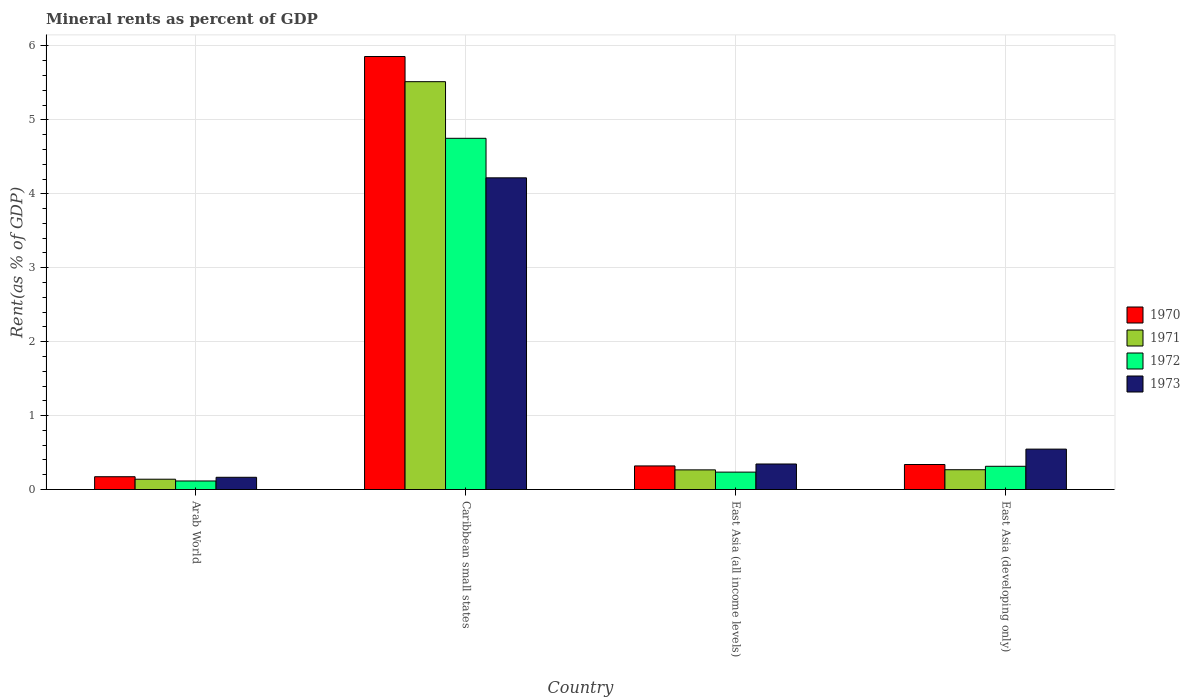How many bars are there on the 2nd tick from the left?
Make the answer very short. 4. How many bars are there on the 2nd tick from the right?
Ensure brevity in your answer.  4. What is the label of the 1st group of bars from the left?
Offer a very short reply. Arab World. What is the mineral rent in 1973 in Arab World?
Your response must be concise. 0.17. Across all countries, what is the maximum mineral rent in 1970?
Your answer should be compact. 5.86. Across all countries, what is the minimum mineral rent in 1970?
Ensure brevity in your answer.  0.17. In which country was the mineral rent in 1973 maximum?
Make the answer very short. Caribbean small states. In which country was the mineral rent in 1972 minimum?
Ensure brevity in your answer.  Arab World. What is the total mineral rent in 1973 in the graph?
Provide a succinct answer. 5.27. What is the difference between the mineral rent in 1972 in Caribbean small states and that in East Asia (developing only)?
Provide a short and direct response. 4.44. What is the difference between the mineral rent in 1970 in Caribbean small states and the mineral rent in 1972 in East Asia (developing only)?
Provide a short and direct response. 5.54. What is the average mineral rent in 1973 per country?
Your answer should be compact. 1.32. What is the difference between the mineral rent of/in 1971 and mineral rent of/in 1972 in Caribbean small states?
Your answer should be compact. 0.77. In how many countries, is the mineral rent in 1972 greater than 3 %?
Offer a very short reply. 1. What is the ratio of the mineral rent in 1972 in Caribbean small states to that in East Asia (developing only)?
Your answer should be compact. 15.12. Is the mineral rent in 1970 in Caribbean small states less than that in East Asia (all income levels)?
Make the answer very short. No. Is the difference between the mineral rent in 1971 in East Asia (all income levels) and East Asia (developing only) greater than the difference between the mineral rent in 1972 in East Asia (all income levels) and East Asia (developing only)?
Offer a very short reply. Yes. What is the difference between the highest and the second highest mineral rent in 1971?
Your answer should be compact. -5.25. What is the difference between the highest and the lowest mineral rent in 1972?
Provide a short and direct response. 4.63. What does the 1st bar from the left in East Asia (developing only) represents?
Your answer should be compact. 1970. Is it the case that in every country, the sum of the mineral rent in 1973 and mineral rent in 1971 is greater than the mineral rent in 1972?
Your answer should be compact. Yes. Are all the bars in the graph horizontal?
Your answer should be very brief. No. How many countries are there in the graph?
Give a very brief answer. 4. What is the difference between two consecutive major ticks on the Y-axis?
Offer a terse response. 1. Are the values on the major ticks of Y-axis written in scientific E-notation?
Give a very brief answer. No. Does the graph contain any zero values?
Provide a succinct answer. No. Does the graph contain grids?
Make the answer very short. Yes. How many legend labels are there?
Make the answer very short. 4. What is the title of the graph?
Your response must be concise. Mineral rents as percent of GDP. Does "1995" appear as one of the legend labels in the graph?
Your answer should be compact. No. What is the label or title of the Y-axis?
Provide a succinct answer. Rent(as % of GDP). What is the Rent(as % of GDP) in 1970 in Arab World?
Offer a terse response. 0.17. What is the Rent(as % of GDP) in 1971 in Arab World?
Ensure brevity in your answer.  0.14. What is the Rent(as % of GDP) in 1972 in Arab World?
Keep it short and to the point. 0.12. What is the Rent(as % of GDP) of 1973 in Arab World?
Provide a short and direct response. 0.17. What is the Rent(as % of GDP) of 1970 in Caribbean small states?
Ensure brevity in your answer.  5.86. What is the Rent(as % of GDP) in 1971 in Caribbean small states?
Your response must be concise. 5.52. What is the Rent(as % of GDP) of 1972 in Caribbean small states?
Offer a very short reply. 4.75. What is the Rent(as % of GDP) in 1973 in Caribbean small states?
Keep it short and to the point. 4.22. What is the Rent(as % of GDP) of 1970 in East Asia (all income levels)?
Keep it short and to the point. 0.32. What is the Rent(as % of GDP) of 1971 in East Asia (all income levels)?
Keep it short and to the point. 0.27. What is the Rent(as % of GDP) of 1972 in East Asia (all income levels)?
Ensure brevity in your answer.  0.24. What is the Rent(as % of GDP) in 1973 in East Asia (all income levels)?
Your answer should be compact. 0.35. What is the Rent(as % of GDP) in 1970 in East Asia (developing only)?
Provide a short and direct response. 0.34. What is the Rent(as % of GDP) of 1971 in East Asia (developing only)?
Offer a very short reply. 0.27. What is the Rent(as % of GDP) in 1972 in East Asia (developing only)?
Give a very brief answer. 0.31. What is the Rent(as % of GDP) of 1973 in East Asia (developing only)?
Keep it short and to the point. 0.55. Across all countries, what is the maximum Rent(as % of GDP) in 1970?
Give a very brief answer. 5.86. Across all countries, what is the maximum Rent(as % of GDP) of 1971?
Offer a very short reply. 5.52. Across all countries, what is the maximum Rent(as % of GDP) in 1972?
Your answer should be very brief. 4.75. Across all countries, what is the maximum Rent(as % of GDP) in 1973?
Offer a terse response. 4.22. Across all countries, what is the minimum Rent(as % of GDP) of 1970?
Provide a succinct answer. 0.17. Across all countries, what is the minimum Rent(as % of GDP) of 1971?
Offer a terse response. 0.14. Across all countries, what is the minimum Rent(as % of GDP) of 1972?
Give a very brief answer. 0.12. Across all countries, what is the minimum Rent(as % of GDP) in 1973?
Your answer should be very brief. 0.17. What is the total Rent(as % of GDP) of 1970 in the graph?
Offer a terse response. 6.69. What is the total Rent(as % of GDP) in 1971 in the graph?
Give a very brief answer. 6.19. What is the total Rent(as % of GDP) in 1972 in the graph?
Ensure brevity in your answer.  5.42. What is the total Rent(as % of GDP) of 1973 in the graph?
Provide a succinct answer. 5.27. What is the difference between the Rent(as % of GDP) of 1970 in Arab World and that in Caribbean small states?
Provide a succinct answer. -5.68. What is the difference between the Rent(as % of GDP) in 1971 in Arab World and that in Caribbean small states?
Give a very brief answer. -5.38. What is the difference between the Rent(as % of GDP) in 1972 in Arab World and that in Caribbean small states?
Provide a succinct answer. -4.63. What is the difference between the Rent(as % of GDP) in 1973 in Arab World and that in Caribbean small states?
Make the answer very short. -4.05. What is the difference between the Rent(as % of GDP) of 1970 in Arab World and that in East Asia (all income levels)?
Make the answer very short. -0.15. What is the difference between the Rent(as % of GDP) of 1971 in Arab World and that in East Asia (all income levels)?
Offer a very short reply. -0.13. What is the difference between the Rent(as % of GDP) of 1972 in Arab World and that in East Asia (all income levels)?
Make the answer very short. -0.12. What is the difference between the Rent(as % of GDP) of 1973 in Arab World and that in East Asia (all income levels)?
Offer a terse response. -0.18. What is the difference between the Rent(as % of GDP) of 1970 in Arab World and that in East Asia (developing only)?
Ensure brevity in your answer.  -0.17. What is the difference between the Rent(as % of GDP) of 1971 in Arab World and that in East Asia (developing only)?
Keep it short and to the point. -0.13. What is the difference between the Rent(as % of GDP) in 1972 in Arab World and that in East Asia (developing only)?
Make the answer very short. -0.2. What is the difference between the Rent(as % of GDP) of 1973 in Arab World and that in East Asia (developing only)?
Ensure brevity in your answer.  -0.38. What is the difference between the Rent(as % of GDP) of 1970 in Caribbean small states and that in East Asia (all income levels)?
Ensure brevity in your answer.  5.54. What is the difference between the Rent(as % of GDP) in 1971 in Caribbean small states and that in East Asia (all income levels)?
Make the answer very short. 5.25. What is the difference between the Rent(as % of GDP) in 1972 in Caribbean small states and that in East Asia (all income levels)?
Offer a very short reply. 4.51. What is the difference between the Rent(as % of GDP) in 1973 in Caribbean small states and that in East Asia (all income levels)?
Provide a short and direct response. 3.87. What is the difference between the Rent(as % of GDP) of 1970 in Caribbean small states and that in East Asia (developing only)?
Your answer should be very brief. 5.52. What is the difference between the Rent(as % of GDP) in 1971 in Caribbean small states and that in East Asia (developing only)?
Your answer should be compact. 5.25. What is the difference between the Rent(as % of GDP) of 1972 in Caribbean small states and that in East Asia (developing only)?
Give a very brief answer. 4.44. What is the difference between the Rent(as % of GDP) of 1973 in Caribbean small states and that in East Asia (developing only)?
Your answer should be very brief. 3.67. What is the difference between the Rent(as % of GDP) of 1970 in East Asia (all income levels) and that in East Asia (developing only)?
Provide a succinct answer. -0.02. What is the difference between the Rent(as % of GDP) in 1971 in East Asia (all income levels) and that in East Asia (developing only)?
Ensure brevity in your answer.  -0. What is the difference between the Rent(as % of GDP) of 1972 in East Asia (all income levels) and that in East Asia (developing only)?
Offer a terse response. -0.08. What is the difference between the Rent(as % of GDP) in 1973 in East Asia (all income levels) and that in East Asia (developing only)?
Offer a very short reply. -0.2. What is the difference between the Rent(as % of GDP) of 1970 in Arab World and the Rent(as % of GDP) of 1971 in Caribbean small states?
Make the answer very short. -5.34. What is the difference between the Rent(as % of GDP) of 1970 in Arab World and the Rent(as % of GDP) of 1972 in Caribbean small states?
Provide a short and direct response. -4.58. What is the difference between the Rent(as % of GDP) in 1970 in Arab World and the Rent(as % of GDP) in 1973 in Caribbean small states?
Make the answer very short. -4.04. What is the difference between the Rent(as % of GDP) of 1971 in Arab World and the Rent(as % of GDP) of 1972 in Caribbean small states?
Your answer should be compact. -4.61. What is the difference between the Rent(as % of GDP) of 1971 in Arab World and the Rent(as % of GDP) of 1973 in Caribbean small states?
Make the answer very short. -4.08. What is the difference between the Rent(as % of GDP) in 1970 in Arab World and the Rent(as % of GDP) in 1971 in East Asia (all income levels)?
Offer a terse response. -0.09. What is the difference between the Rent(as % of GDP) of 1970 in Arab World and the Rent(as % of GDP) of 1972 in East Asia (all income levels)?
Keep it short and to the point. -0.06. What is the difference between the Rent(as % of GDP) in 1970 in Arab World and the Rent(as % of GDP) in 1973 in East Asia (all income levels)?
Give a very brief answer. -0.17. What is the difference between the Rent(as % of GDP) of 1971 in Arab World and the Rent(as % of GDP) of 1972 in East Asia (all income levels)?
Give a very brief answer. -0.1. What is the difference between the Rent(as % of GDP) in 1971 in Arab World and the Rent(as % of GDP) in 1973 in East Asia (all income levels)?
Your answer should be very brief. -0.21. What is the difference between the Rent(as % of GDP) in 1972 in Arab World and the Rent(as % of GDP) in 1973 in East Asia (all income levels)?
Offer a very short reply. -0.23. What is the difference between the Rent(as % of GDP) of 1970 in Arab World and the Rent(as % of GDP) of 1971 in East Asia (developing only)?
Offer a very short reply. -0.09. What is the difference between the Rent(as % of GDP) of 1970 in Arab World and the Rent(as % of GDP) of 1972 in East Asia (developing only)?
Offer a terse response. -0.14. What is the difference between the Rent(as % of GDP) of 1970 in Arab World and the Rent(as % of GDP) of 1973 in East Asia (developing only)?
Provide a short and direct response. -0.37. What is the difference between the Rent(as % of GDP) of 1971 in Arab World and the Rent(as % of GDP) of 1972 in East Asia (developing only)?
Ensure brevity in your answer.  -0.17. What is the difference between the Rent(as % of GDP) of 1971 in Arab World and the Rent(as % of GDP) of 1973 in East Asia (developing only)?
Provide a succinct answer. -0.41. What is the difference between the Rent(as % of GDP) in 1972 in Arab World and the Rent(as % of GDP) in 1973 in East Asia (developing only)?
Your response must be concise. -0.43. What is the difference between the Rent(as % of GDP) of 1970 in Caribbean small states and the Rent(as % of GDP) of 1971 in East Asia (all income levels)?
Your answer should be very brief. 5.59. What is the difference between the Rent(as % of GDP) in 1970 in Caribbean small states and the Rent(as % of GDP) in 1972 in East Asia (all income levels)?
Give a very brief answer. 5.62. What is the difference between the Rent(as % of GDP) of 1970 in Caribbean small states and the Rent(as % of GDP) of 1973 in East Asia (all income levels)?
Keep it short and to the point. 5.51. What is the difference between the Rent(as % of GDP) in 1971 in Caribbean small states and the Rent(as % of GDP) in 1972 in East Asia (all income levels)?
Ensure brevity in your answer.  5.28. What is the difference between the Rent(as % of GDP) of 1971 in Caribbean small states and the Rent(as % of GDP) of 1973 in East Asia (all income levels)?
Provide a succinct answer. 5.17. What is the difference between the Rent(as % of GDP) in 1972 in Caribbean small states and the Rent(as % of GDP) in 1973 in East Asia (all income levels)?
Offer a very short reply. 4.41. What is the difference between the Rent(as % of GDP) in 1970 in Caribbean small states and the Rent(as % of GDP) in 1971 in East Asia (developing only)?
Ensure brevity in your answer.  5.59. What is the difference between the Rent(as % of GDP) in 1970 in Caribbean small states and the Rent(as % of GDP) in 1972 in East Asia (developing only)?
Your answer should be compact. 5.54. What is the difference between the Rent(as % of GDP) of 1970 in Caribbean small states and the Rent(as % of GDP) of 1973 in East Asia (developing only)?
Give a very brief answer. 5.31. What is the difference between the Rent(as % of GDP) of 1971 in Caribbean small states and the Rent(as % of GDP) of 1972 in East Asia (developing only)?
Your response must be concise. 5.2. What is the difference between the Rent(as % of GDP) in 1971 in Caribbean small states and the Rent(as % of GDP) in 1973 in East Asia (developing only)?
Your response must be concise. 4.97. What is the difference between the Rent(as % of GDP) of 1972 in Caribbean small states and the Rent(as % of GDP) of 1973 in East Asia (developing only)?
Your response must be concise. 4.2. What is the difference between the Rent(as % of GDP) of 1970 in East Asia (all income levels) and the Rent(as % of GDP) of 1971 in East Asia (developing only)?
Offer a terse response. 0.05. What is the difference between the Rent(as % of GDP) in 1970 in East Asia (all income levels) and the Rent(as % of GDP) in 1972 in East Asia (developing only)?
Provide a short and direct response. 0. What is the difference between the Rent(as % of GDP) in 1970 in East Asia (all income levels) and the Rent(as % of GDP) in 1973 in East Asia (developing only)?
Provide a succinct answer. -0.23. What is the difference between the Rent(as % of GDP) in 1971 in East Asia (all income levels) and the Rent(as % of GDP) in 1972 in East Asia (developing only)?
Offer a very short reply. -0.05. What is the difference between the Rent(as % of GDP) of 1971 in East Asia (all income levels) and the Rent(as % of GDP) of 1973 in East Asia (developing only)?
Keep it short and to the point. -0.28. What is the difference between the Rent(as % of GDP) in 1972 in East Asia (all income levels) and the Rent(as % of GDP) in 1973 in East Asia (developing only)?
Provide a short and direct response. -0.31. What is the average Rent(as % of GDP) of 1970 per country?
Make the answer very short. 1.67. What is the average Rent(as % of GDP) of 1971 per country?
Offer a terse response. 1.55. What is the average Rent(as % of GDP) of 1972 per country?
Keep it short and to the point. 1.35. What is the average Rent(as % of GDP) of 1973 per country?
Ensure brevity in your answer.  1.32. What is the difference between the Rent(as % of GDP) in 1970 and Rent(as % of GDP) in 1971 in Arab World?
Ensure brevity in your answer.  0.03. What is the difference between the Rent(as % of GDP) in 1970 and Rent(as % of GDP) in 1972 in Arab World?
Provide a short and direct response. 0.06. What is the difference between the Rent(as % of GDP) of 1970 and Rent(as % of GDP) of 1973 in Arab World?
Offer a very short reply. 0.01. What is the difference between the Rent(as % of GDP) of 1971 and Rent(as % of GDP) of 1972 in Arab World?
Offer a very short reply. 0.02. What is the difference between the Rent(as % of GDP) of 1971 and Rent(as % of GDP) of 1973 in Arab World?
Your answer should be very brief. -0.03. What is the difference between the Rent(as % of GDP) in 1972 and Rent(as % of GDP) in 1973 in Arab World?
Give a very brief answer. -0.05. What is the difference between the Rent(as % of GDP) of 1970 and Rent(as % of GDP) of 1971 in Caribbean small states?
Make the answer very short. 0.34. What is the difference between the Rent(as % of GDP) of 1970 and Rent(as % of GDP) of 1972 in Caribbean small states?
Provide a succinct answer. 1.11. What is the difference between the Rent(as % of GDP) of 1970 and Rent(as % of GDP) of 1973 in Caribbean small states?
Your response must be concise. 1.64. What is the difference between the Rent(as % of GDP) of 1971 and Rent(as % of GDP) of 1972 in Caribbean small states?
Your answer should be very brief. 0.77. What is the difference between the Rent(as % of GDP) in 1971 and Rent(as % of GDP) in 1973 in Caribbean small states?
Keep it short and to the point. 1.3. What is the difference between the Rent(as % of GDP) in 1972 and Rent(as % of GDP) in 1973 in Caribbean small states?
Keep it short and to the point. 0.53. What is the difference between the Rent(as % of GDP) in 1970 and Rent(as % of GDP) in 1971 in East Asia (all income levels)?
Offer a terse response. 0.05. What is the difference between the Rent(as % of GDP) in 1970 and Rent(as % of GDP) in 1972 in East Asia (all income levels)?
Keep it short and to the point. 0.08. What is the difference between the Rent(as % of GDP) in 1970 and Rent(as % of GDP) in 1973 in East Asia (all income levels)?
Your answer should be compact. -0.03. What is the difference between the Rent(as % of GDP) in 1971 and Rent(as % of GDP) in 1972 in East Asia (all income levels)?
Make the answer very short. 0.03. What is the difference between the Rent(as % of GDP) of 1971 and Rent(as % of GDP) of 1973 in East Asia (all income levels)?
Provide a short and direct response. -0.08. What is the difference between the Rent(as % of GDP) of 1972 and Rent(as % of GDP) of 1973 in East Asia (all income levels)?
Your answer should be very brief. -0.11. What is the difference between the Rent(as % of GDP) in 1970 and Rent(as % of GDP) in 1971 in East Asia (developing only)?
Your answer should be compact. 0.07. What is the difference between the Rent(as % of GDP) of 1970 and Rent(as % of GDP) of 1972 in East Asia (developing only)?
Your response must be concise. 0.02. What is the difference between the Rent(as % of GDP) in 1970 and Rent(as % of GDP) in 1973 in East Asia (developing only)?
Your response must be concise. -0.21. What is the difference between the Rent(as % of GDP) in 1971 and Rent(as % of GDP) in 1972 in East Asia (developing only)?
Give a very brief answer. -0.05. What is the difference between the Rent(as % of GDP) of 1971 and Rent(as % of GDP) of 1973 in East Asia (developing only)?
Keep it short and to the point. -0.28. What is the difference between the Rent(as % of GDP) of 1972 and Rent(as % of GDP) of 1973 in East Asia (developing only)?
Offer a terse response. -0.23. What is the ratio of the Rent(as % of GDP) in 1970 in Arab World to that in Caribbean small states?
Offer a very short reply. 0.03. What is the ratio of the Rent(as % of GDP) of 1971 in Arab World to that in Caribbean small states?
Your response must be concise. 0.03. What is the ratio of the Rent(as % of GDP) in 1972 in Arab World to that in Caribbean small states?
Offer a terse response. 0.02. What is the ratio of the Rent(as % of GDP) in 1973 in Arab World to that in Caribbean small states?
Offer a very short reply. 0.04. What is the ratio of the Rent(as % of GDP) in 1970 in Arab World to that in East Asia (all income levels)?
Ensure brevity in your answer.  0.54. What is the ratio of the Rent(as % of GDP) in 1971 in Arab World to that in East Asia (all income levels)?
Provide a short and direct response. 0.52. What is the ratio of the Rent(as % of GDP) in 1972 in Arab World to that in East Asia (all income levels)?
Offer a very short reply. 0.49. What is the ratio of the Rent(as % of GDP) in 1973 in Arab World to that in East Asia (all income levels)?
Your answer should be very brief. 0.48. What is the ratio of the Rent(as % of GDP) of 1970 in Arab World to that in East Asia (developing only)?
Provide a short and direct response. 0.51. What is the ratio of the Rent(as % of GDP) in 1971 in Arab World to that in East Asia (developing only)?
Your answer should be very brief. 0.52. What is the ratio of the Rent(as % of GDP) of 1972 in Arab World to that in East Asia (developing only)?
Provide a short and direct response. 0.37. What is the ratio of the Rent(as % of GDP) of 1973 in Arab World to that in East Asia (developing only)?
Provide a succinct answer. 0.3. What is the ratio of the Rent(as % of GDP) in 1970 in Caribbean small states to that in East Asia (all income levels)?
Your response must be concise. 18.36. What is the ratio of the Rent(as % of GDP) in 1971 in Caribbean small states to that in East Asia (all income levels)?
Keep it short and to the point. 20.76. What is the ratio of the Rent(as % of GDP) in 1972 in Caribbean small states to that in East Asia (all income levels)?
Your answer should be compact. 20.18. What is the ratio of the Rent(as % of GDP) in 1973 in Caribbean small states to that in East Asia (all income levels)?
Provide a succinct answer. 12.21. What is the ratio of the Rent(as % of GDP) of 1970 in Caribbean small states to that in East Asia (developing only)?
Give a very brief answer. 17.32. What is the ratio of the Rent(as % of GDP) in 1971 in Caribbean small states to that in East Asia (developing only)?
Provide a succinct answer. 20.61. What is the ratio of the Rent(as % of GDP) in 1972 in Caribbean small states to that in East Asia (developing only)?
Offer a terse response. 15.12. What is the ratio of the Rent(as % of GDP) in 1973 in Caribbean small states to that in East Asia (developing only)?
Your answer should be compact. 7.71. What is the ratio of the Rent(as % of GDP) of 1970 in East Asia (all income levels) to that in East Asia (developing only)?
Provide a short and direct response. 0.94. What is the ratio of the Rent(as % of GDP) in 1971 in East Asia (all income levels) to that in East Asia (developing only)?
Ensure brevity in your answer.  0.99. What is the ratio of the Rent(as % of GDP) of 1972 in East Asia (all income levels) to that in East Asia (developing only)?
Your answer should be compact. 0.75. What is the ratio of the Rent(as % of GDP) in 1973 in East Asia (all income levels) to that in East Asia (developing only)?
Offer a terse response. 0.63. What is the difference between the highest and the second highest Rent(as % of GDP) of 1970?
Your response must be concise. 5.52. What is the difference between the highest and the second highest Rent(as % of GDP) in 1971?
Offer a very short reply. 5.25. What is the difference between the highest and the second highest Rent(as % of GDP) of 1972?
Keep it short and to the point. 4.44. What is the difference between the highest and the second highest Rent(as % of GDP) of 1973?
Make the answer very short. 3.67. What is the difference between the highest and the lowest Rent(as % of GDP) of 1970?
Provide a succinct answer. 5.68. What is the difference between the highest and the lowest Rent(as % of GDP) of 1971?
Ensure brevity in your answer.  5.38. What is the difference between the highest and the lowest Rent(as % of GDP) in 1972?
Your response must be concise. 4.63. What is the difference between the highest and the lowest Rent(as % of GDP) in 1973?
Your answer should be very brief. 4.05. 